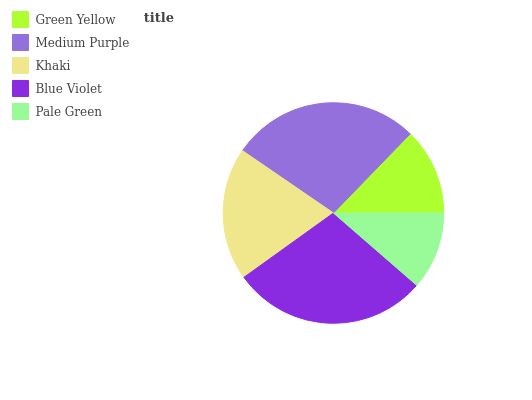Is Pale Green the minimum?
Answer yes or no. Yes. Is Blue Violet the maximum?
Answer yes or no. Yes. Is Medium Purple the minimum?
Answer yes or no. No. Is Medium Purple the maximum?
Answer yes or no. No. Is Medium Purple greater than Green Yellow?
Answer yes or no. Yes. Is Green Yellow less than Medium Purple?
Answer yes or no. Yes. Is Green Yellow greater than Medium Purple?
Answer yes or no. No. Is Medium Purple less than Green Yellow?
Answer yes or no. No. Is Khaki the high median?
Answer yes or no. Yes. Is Khaki the low median?
Answer yes or no. Yes. Is Pale Green the high median?
Answer yes or no. No. Is Pale Green the low median?
Answer yes or no. No. 